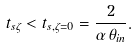Convert formula to latex. <formula><loc_0><loc_0><loc_500><loc_500>t _ { s \zeta } < t _ { s , \zeta = 0 } = \frac { 2 } { \alpha \, \theta _ { i n } } .</formula> 